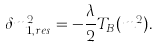<formula> <loc_0><loc_0><loc_500><loc_500>\delta m _ { 1 , r e s } ^ { 2 } = - \frac { \lambda } { 2 } T _ { B } ( m ^ { 2 } ) .</formula> 